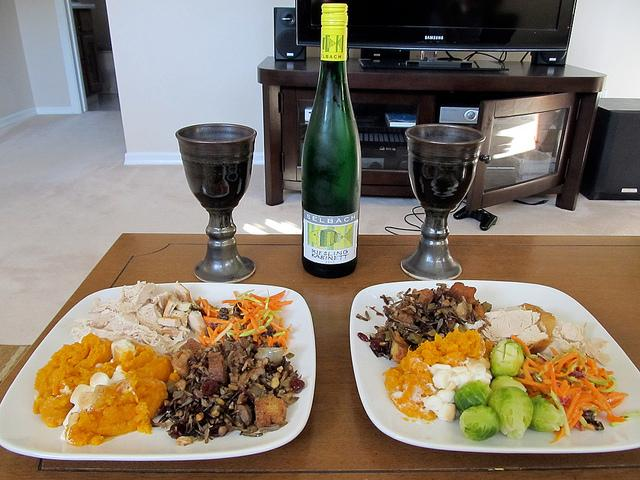Where in the house are they likely planning to dine?

Choices:
A) living room
B) porch
C) kitchen
D) dining room living room 